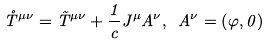<formula> <loc_0><loc_0><loc_500><loc_500>\mathring { T } ^ { \mu \nu } = \tilde { T } ^ { \mu \nu } + \frac { 1 } { c } J ^ { \mu } A ^ { \nu } , \ A ^ { \nu } = \left ( \varphi , 0 \right )</formula> 